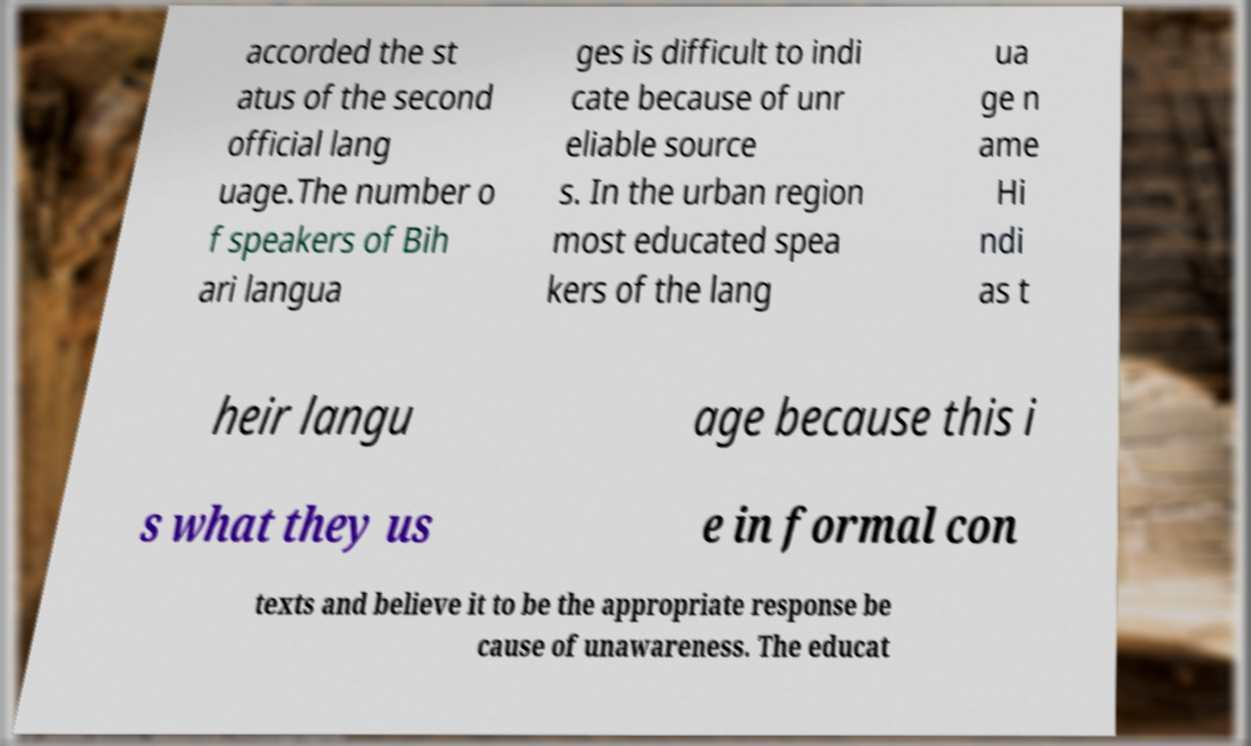What messages or text are displayed in this image? I need them in a readable, typed format. accorded the st atus of the second official lang uage.The number o f speakers of Bih ari langua ges is difficult to indi cate because of unr eliable source s. In the urban region most educated spea kers of the lang ua ge n ame Hi ndi as t heir langu age because this i s what they us e in formal con texts and believe it to be the appropriate response be cause of unawareness. The educat 